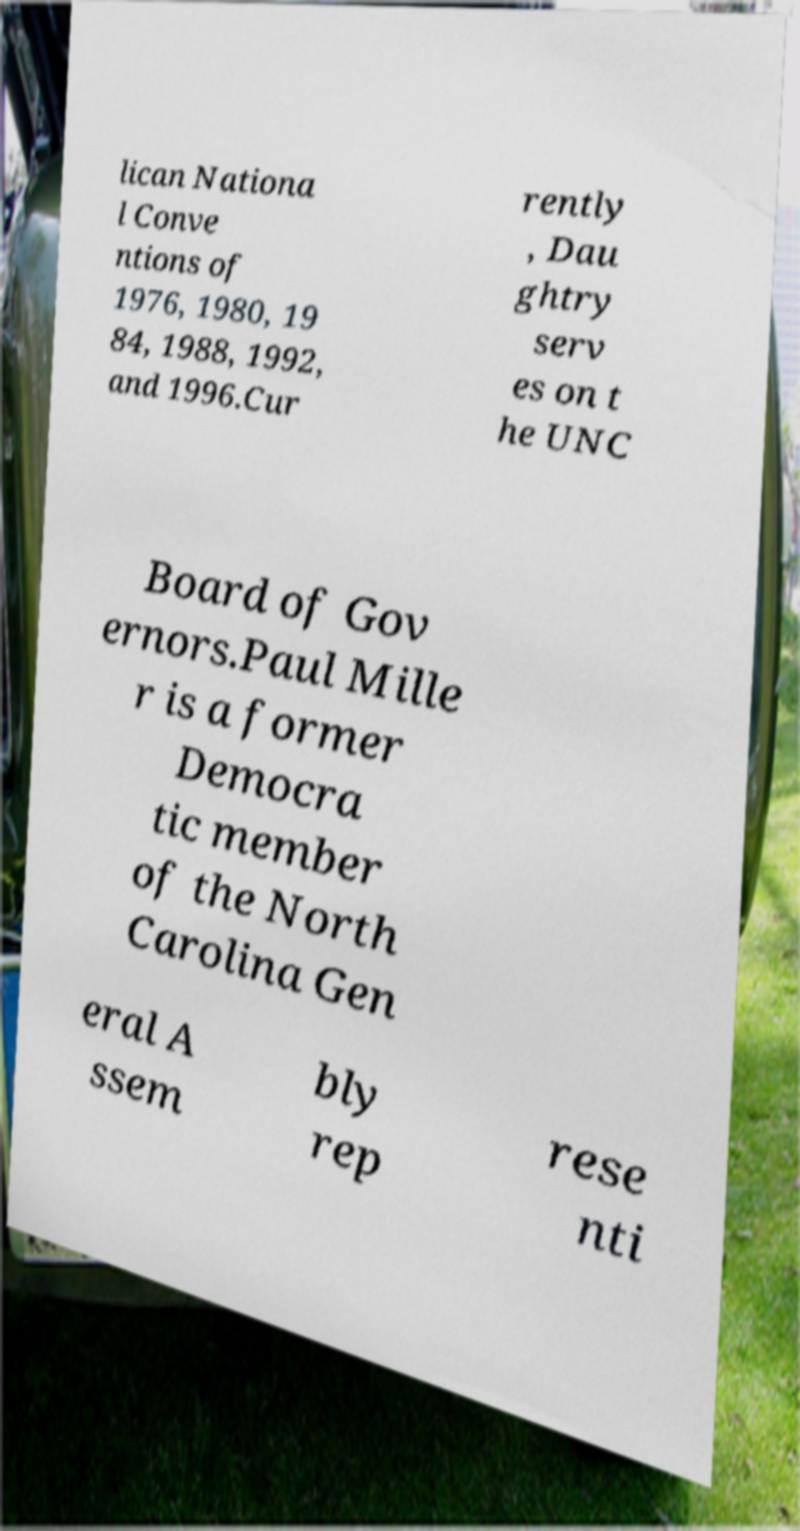Can you accurately transcribe the text from the provided image for me? lican Nationa l Conve ntions of 1976, 1980, 19 84, 1988, 1992, and 1996.Cur rently , Dau ghtry serv es on t he UNC Board of Gov ernors.Paul Mille r is a former Democra tic member of the North Carolina Gen eral A ssem bly rep rese nti 